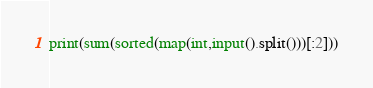Convert code to text. <code><loc_0><loc_0><loc_500><loc_500><_Python_>print(sum(sorted(map(int,input().split()))[:2]))</code> 